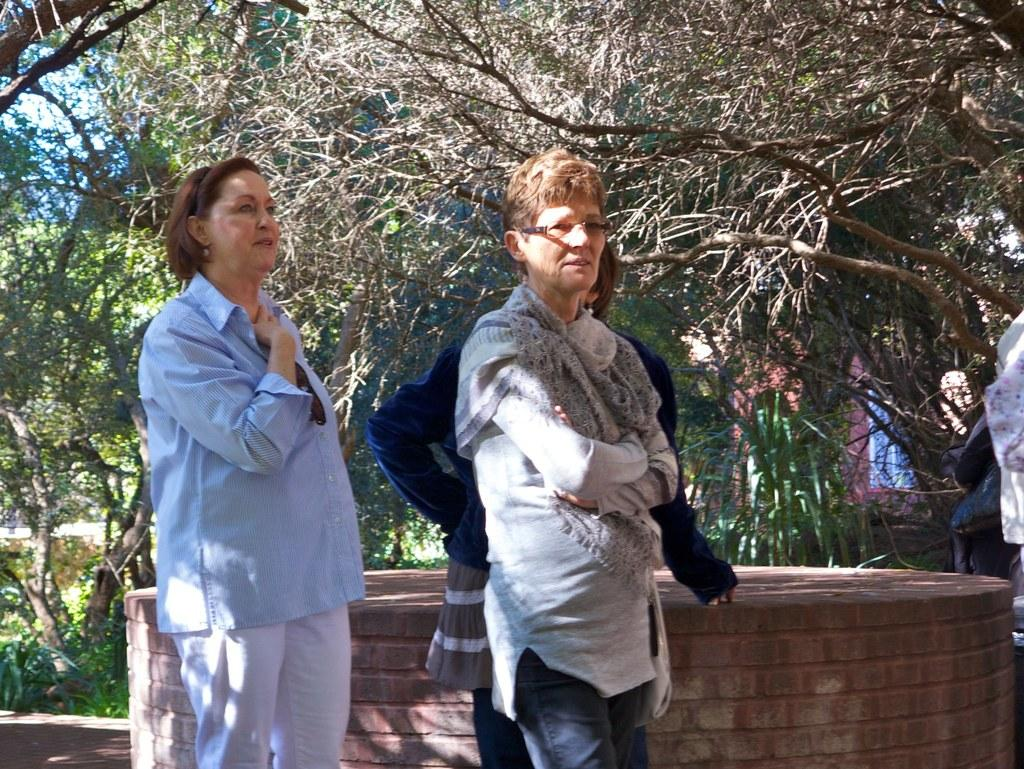How many people are present in the image? There are persons standing in the image. What type of structure can be seen in the background? There is a brick wall in the image. What type of vegetation is visible in the image? There are trees and plants in the image. What type of structure is present in the image? There is a building in the image. What part of the natural environment is visible in the image? The sky is visible in the image. Can you see any cracks in the robin's stem in the image? There is no robin or stem present in the image. 